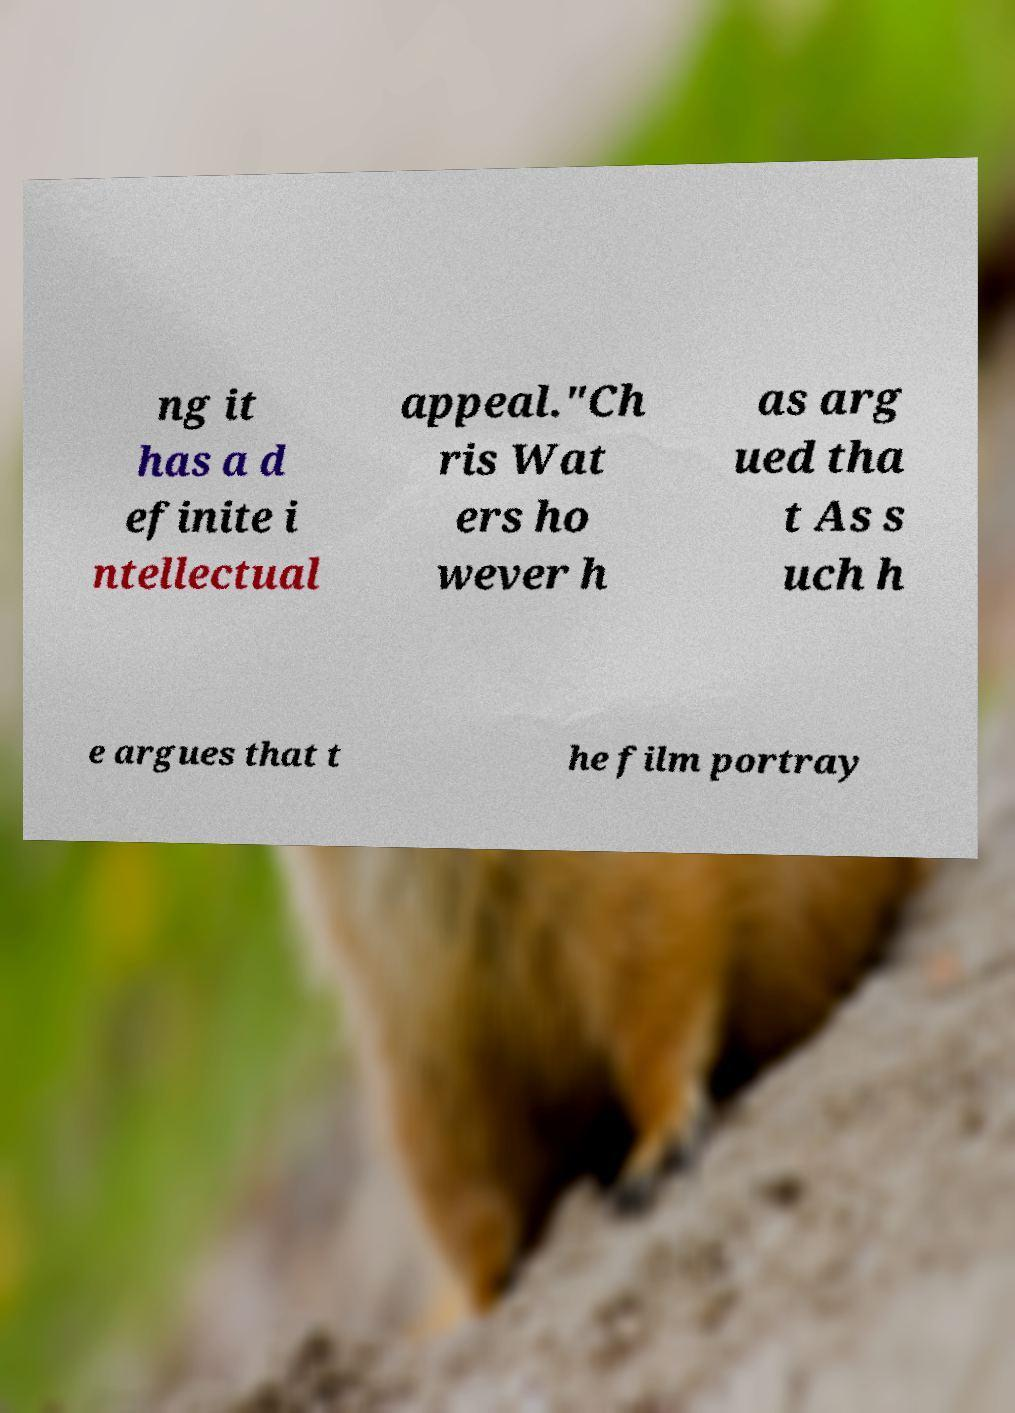Please identify and transcribe the text found in this image. ng it has a d efinite i ntellectual appeal."Ch ris Wat ers ho wever h as arg ued tha t As s uch h e argues that t he film portray 